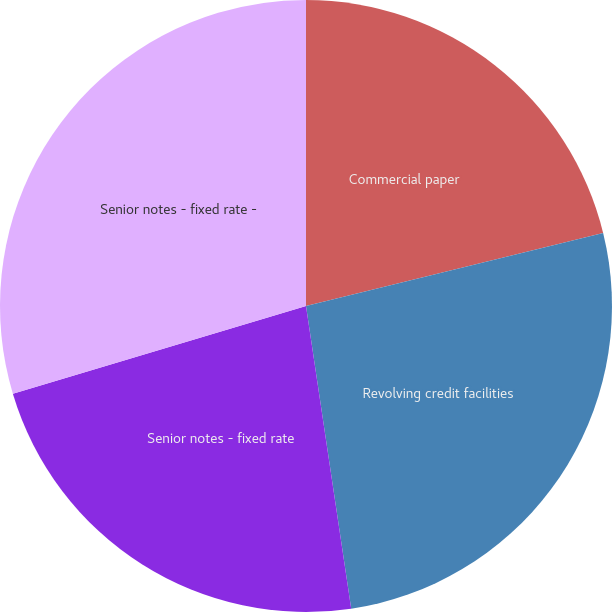Convert chart to OTSL. <chart><loc_0><loc_0><loc_500><loc_500><pie_chart><fcel>Commercial paper<fcel>Revolving credit facilities<fcel>Senior notes - fixed rate<fcel>Senior notes - fixed rate -<nl><fcel>21.16%<fcel>26.48%<fcel>22.73%<fcel>29.63%<nl></chart> 